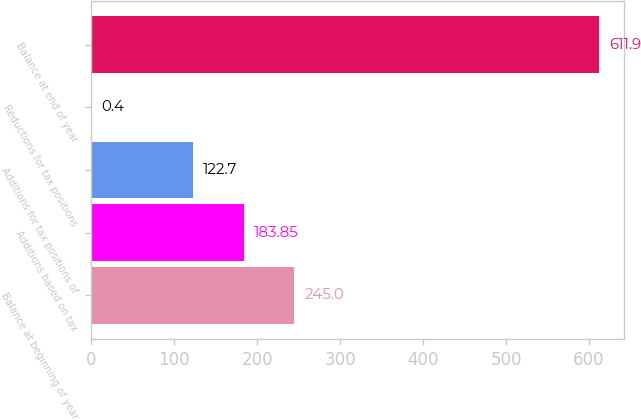<chart> <loc_0><loc_0><loc_500><loc_500><bar_chart><fcel>Balance at beginning of year<fcel>Additions based on tax<fcel>Additions for tax positions of<fcel>Reductions for tax positions<fcel>Balance at end of year<nl><fcel>245<fcel>183.85<fcel>122.7<fcel>0.4<fcel>611.9<nl></chart> 